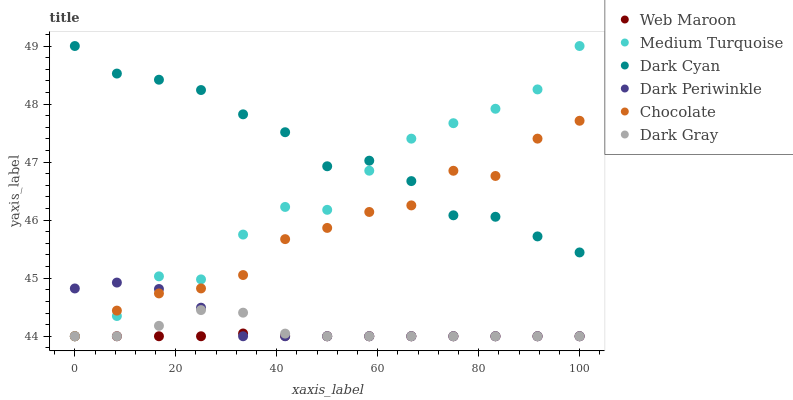Does Web Maroon have the minimum area under the curve?
Answer yes or no. Yes. Does Dark Cyan have the maximum area under the curve?
Answer yes or no. Yes. Does Chocolate have the minimum area under the curve?
Answer yes or no. No. Does Chocolate have the maximum area under the curve?
Answer yes or no. No. Is Web Maroon the smoothest?
Answer yes or no. Yes. Is Medium Turquoise the roughest?
Answer yes or no. Yes. Is Chocolate the smoothest?
Answer yes or no. No. Is Chocolate the roughest?
Answer yes or no. No. Does Web Maroon have the lowest value?
Answer yes or no. Yes. Does Dark Cyan have the lowest value?
Answer yes or no. No. Does Dark Cyan have the highest value?
Answer yes or no. Yes. Does Chocolate have the highest value?
Answer yes or no. No. Is Web Maroon less than Dark Cyan?
Answer yes or no. Yes. Is Dark Cyan greater than Web Maroon?
Answer yes or no. Yes. Does Dark Gray intersect Dark Periwinkle?
Answer yes or no. Yes. Is Dark Gray less than Dark Periwinkle?
Answer yes or no. No. Is Dark Gray greater than Dark Periwinkle?
Answer yes or no. No. Does Web Maroon intersect Dark Cyan?
Answer yes or no. No. 